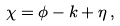Convert formula to latex. <formula><loc_0><loc_0><loc_500><loc_500>\chi = \phi - k + \eta \, ,</formula> 